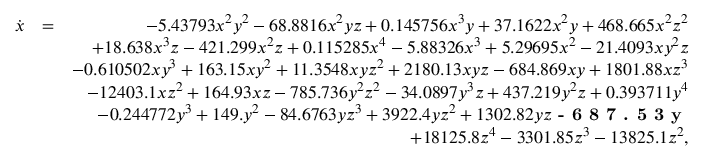<formula> <loc_0><loc_0><loc_500><loc_500>\begin{array} { r l r } { \dot { x } } & { = } & { - 5 . 4 3 7 9 3 x ^ { 2 } y ^ { 2 } - 6 8 . 8 8 1 6 x ^ { 2 } y z + 0 . 1 4 5 7 5 6 x ^ { 3 } y + 3 7 . 1 6 2 2 x ^ { 2 } y + 4 6 8 . 6 6 5 x ^ { 2 } z ^ { 2 } } \\ & { + 1 8 . 6 3 8 x ^ { 3 } z - 4 2 1 . 2 9 9 x ^ { 2 } z + 0 . 1 1 5 2 8 5 x ^ { 4 } - 5 . 8 8 3 2 6 x ^ { 3 } + 5 . 2 9 6 9 5 x ^ { 2 } - 2 1 . 4 0 9 3 x y ^ { 2 } z } \\ & { - 0 . 6 1 0 5 0 2 x y ^ { 3 } + 1 6 3 . 1 5 x y ^ { 2 } + 1 1 . 3 5 4 8 x y z ^ { 2 } + 2 1 8 0 . 1 3 x y z - 6 8 4 . 8 6 9 x y + 1 8 0 1 . 8 8 x z ^ { 3 } } \\ & { - 1 2 4 0 3 . 1 x z ^ { 2 } + 1 6 4 . 9 3 x z - 7 8 5 . 7 3 6 y ^ { 2 } z ^ { 2 } - 3 4 . 0 8 9 7 y ^ { 3 } z + 4 3 7 . 2 1 9 y ^ { 2 } z + 0 . 3 9 3 7 1 1 y ^ { 4 } } \\ & { - 0 . 2 4 4 7 7 2 y ^ { 3 } + 1 4 9 . y ^ { 2 } - 8 4 . 6 7 6 3 y z ^ { 3 } + 3 9 2 2 . 4 y z ^ { 2 } + 1 3 0 2 . 8 2 y z - 6 8 7 . 5 3 y } \\ & { + 1 8 1 2 5 . 8 z ^ { 4 } - 3 3 0 1 . 8 5 z ^ { 3 } - 1 3 8 2 5 . 1 z ^ { 2 } , } \end{array}</formula> 